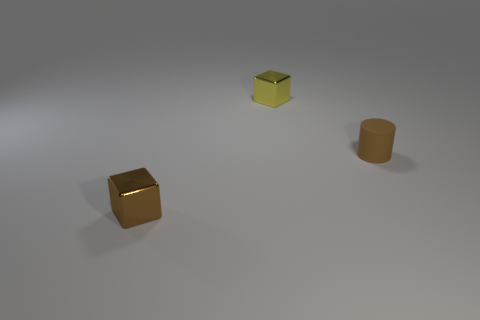Are there an equal number of tiny brown cylinders that are left of the tiny rubber cylinder and brown cylinders?
Your answer should be compact. No. Are there any brown things behind the tiny cylinder?
Ensure brevity in your answer.  No. How many metal objects are small yellow balls or yellow things?
Offer a very short reply. 1. There is a brown shiny block; how many small metal cubes are in front of it?
Keep it short and to the point. 0. Are there any gray matte balls that have the same size as the brown matte cylinder?
Your answer should be compact. No. Are there any small cylinders that have the same color as the matte object?
Give a very brief answer. No. Is there anything else that has the same size as the yellow metal cube?
Keep it short and to the point. Yes. What number of matte objects are the same color as the cylinder?
Make the answer very short. 0. There is a rubber thing; is its color the same as the small shiny thing that is behind the brown metallic thing?
Your answer should be very brief. No. How many things are big green metallic balls or small objects behind the rubber cylinder?
Ensure brevity in your answer.  1. 